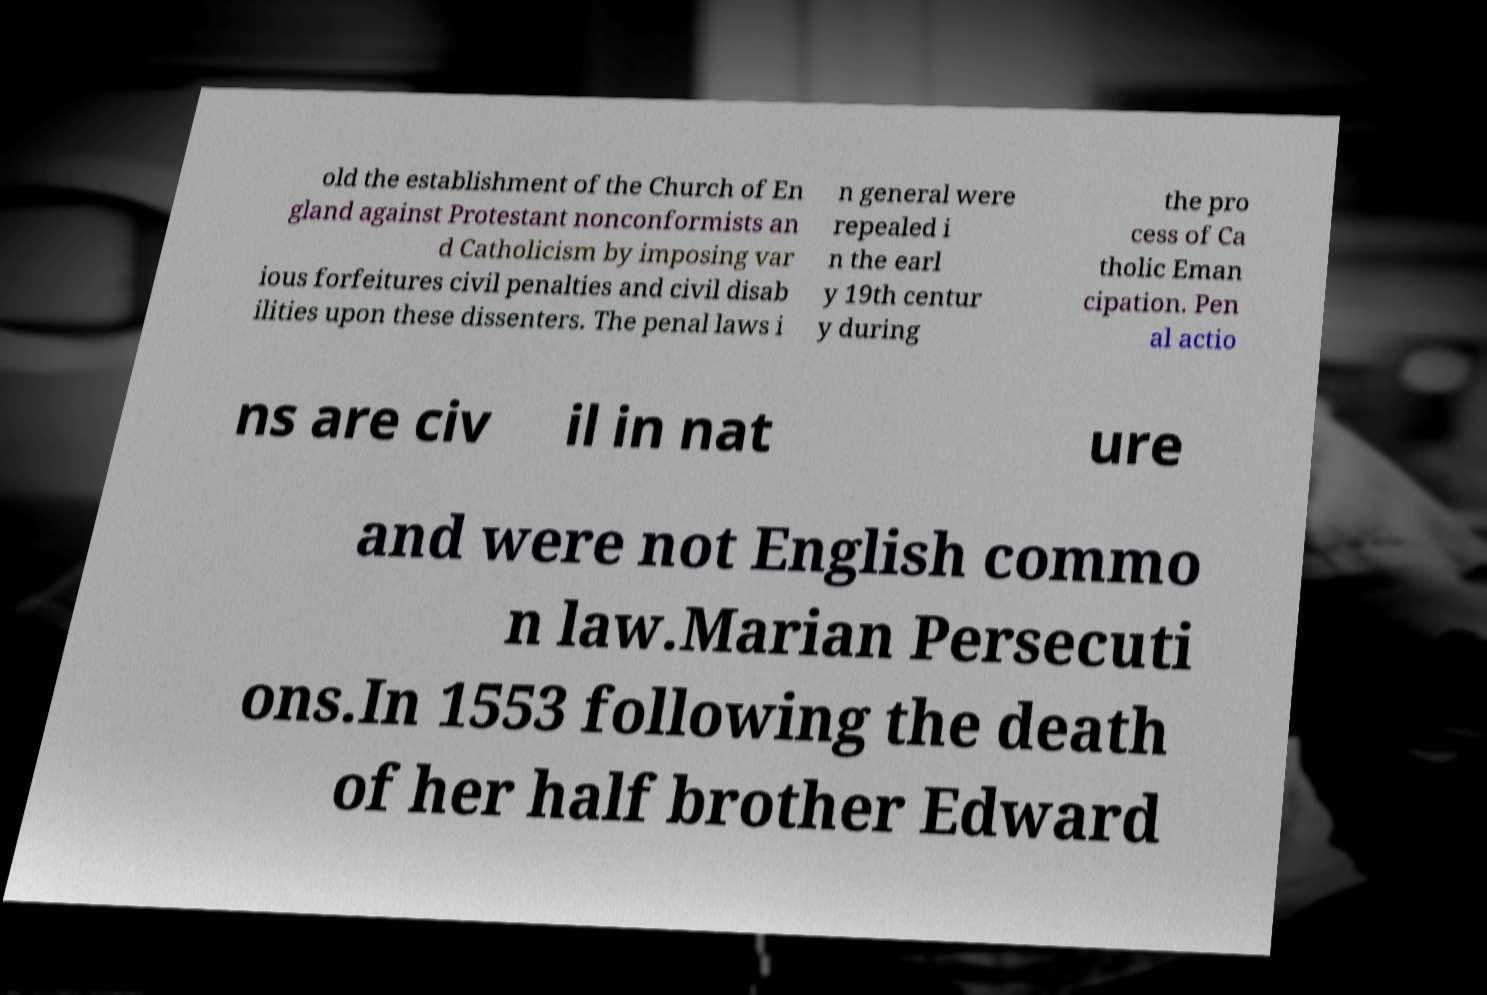There's text embedded in this image that I need extracted. Can you transcribe it verbatim? old the establishment of the Church of En gland against Protestant nonconformists an d Catholicism by imposing var ious forfeitures civil penalties and civil disab ilities upon these dissenters. The penal laws i n general were repealed i n the earl y 19th centur y during the pro cess of Ca tholic Eman cipation. Pen al actio ns are civ il in nat ure and were not English commo n law.Marian Persecuti ons.In 1553 following the death of her half brother Edward 